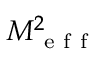Convert formula to latex. <formula><loc_0><loc_0><loc_500><loc_500>M _ { e f f } ^ { 2 }</formula> 